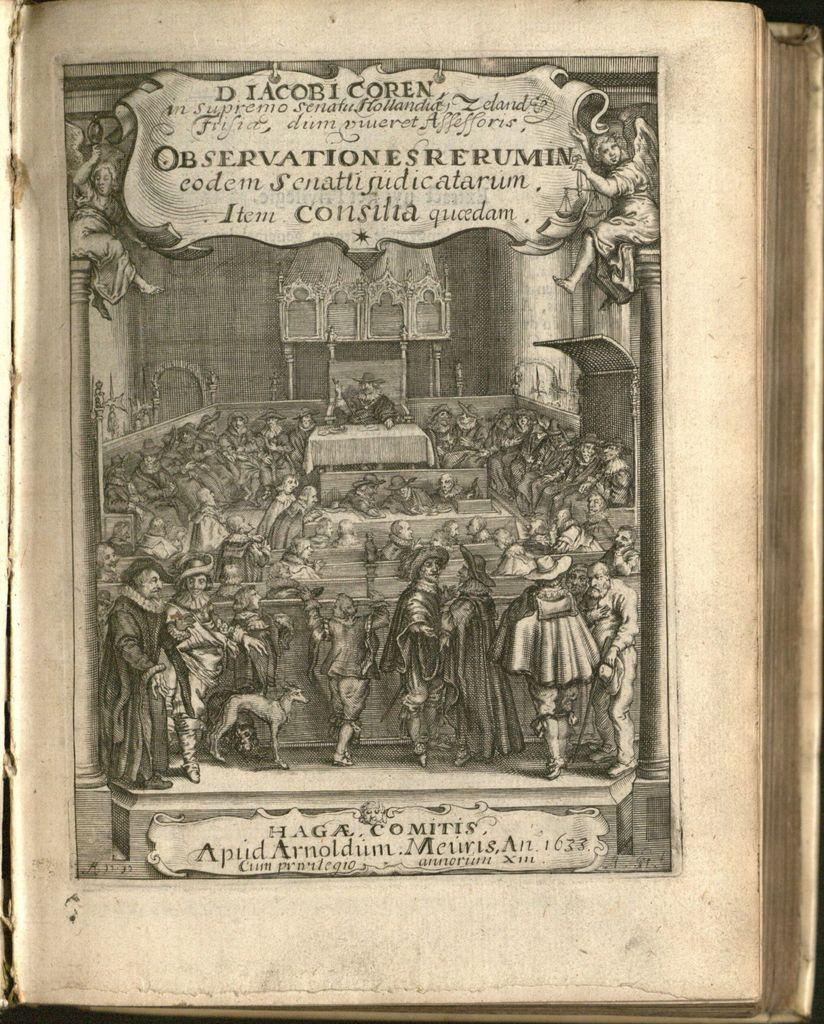<image>
Summarize the visual content of the image. Page of a book that says "Apud Arnoldum Meuris" on the bottom. 